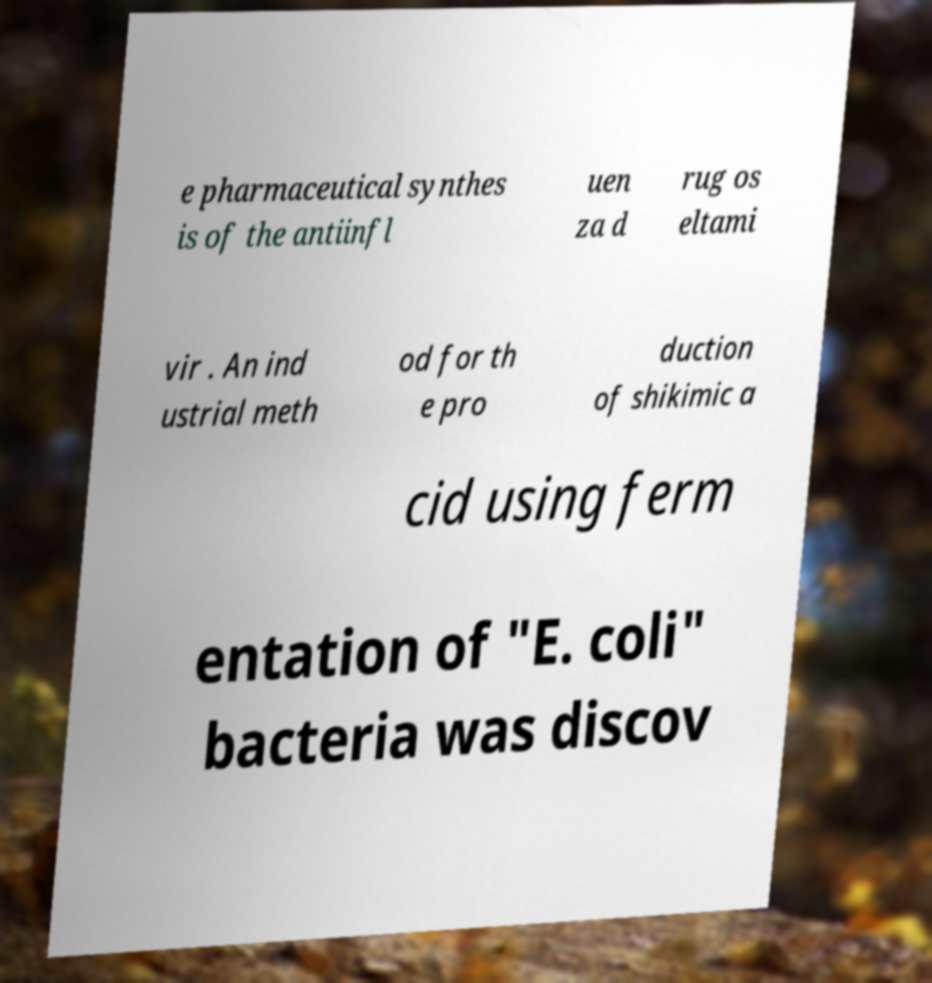Could you extract and type out the text from this image? e pharmaceutical synthes is of the antiinfl uen za d rug os eltami vir . An ind ustrial meth od for th e pro duction of shikimic a cid using ferm entation of "E. coli" bacteria was discov 